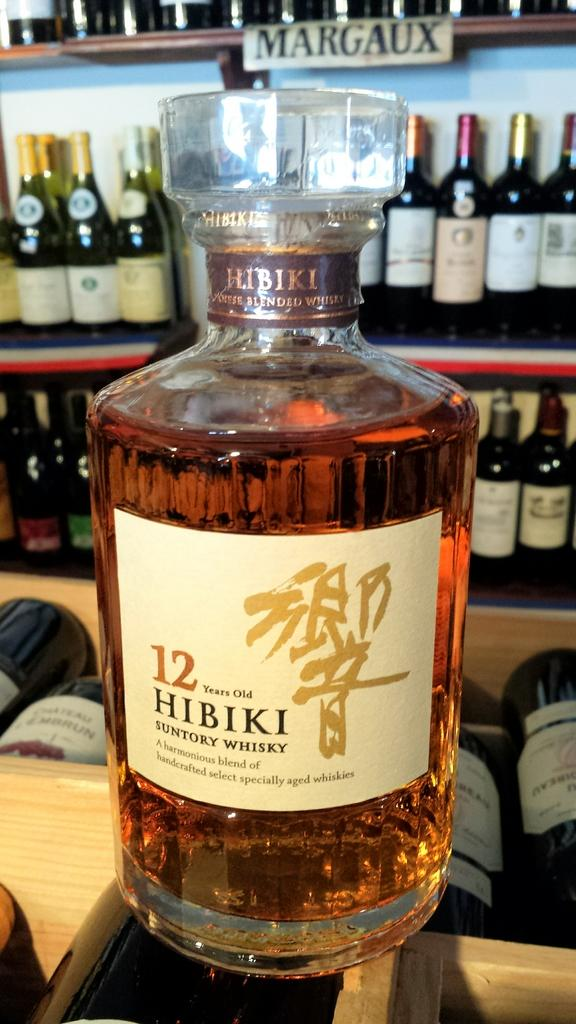Provide a one-sentence caption for the provided image. The alcoholic beverage in the glass bottle is 12 years old. 